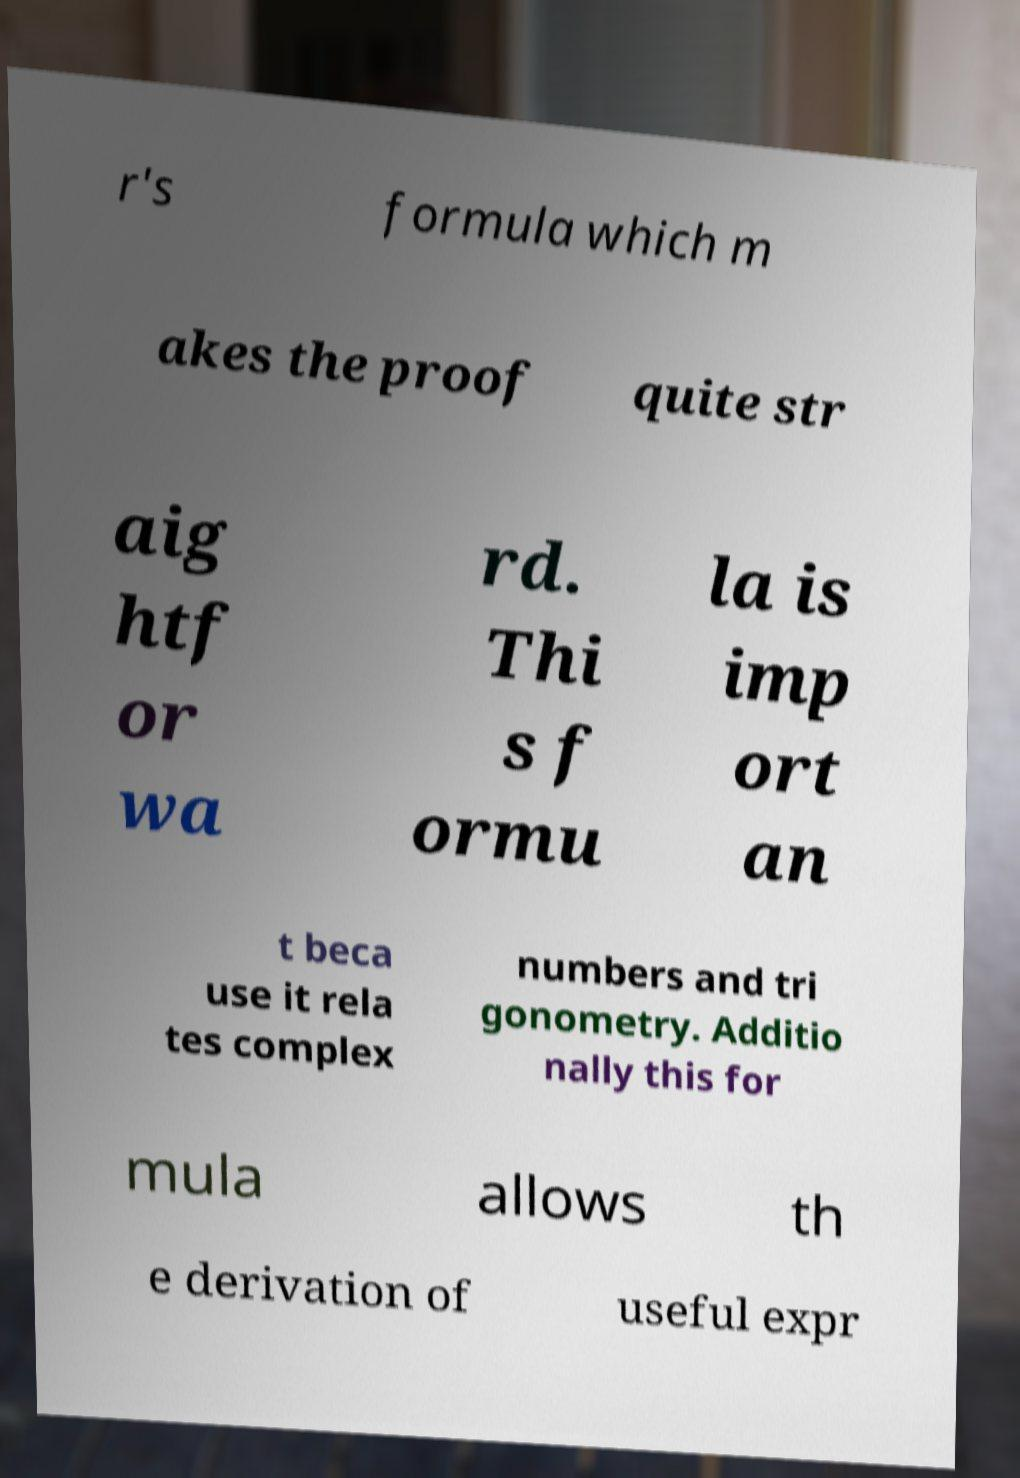There's text embedded in this image that I need extracted. Can you transcribe it verbatim? r's formula which m akes the proof quite str aig htf or wa rd. Thi s f ormu la is imp ort an t beca use it rela tes complex numbers and tri gonometry. Additio nally this for mula allows th e derivation of useful expr 